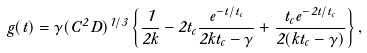<formula> <loc_0><loc_0><loc_500><loc_500>g ( t ) = \gamma ( C ^ { 2 } D ) ^ { 1 / 3 } \left \{ \frac { 1 } { 2 k } - 2 t _ { c } \frac { e ^ { - t / t _ { c } } } { 2 k t _ { c } - \gamma } + \frac { t _ { c } e ^ { - 2 t / t _ { c } } } { 2 ( k t _ { c } - \gamma ) } \right \} ,</formula> 